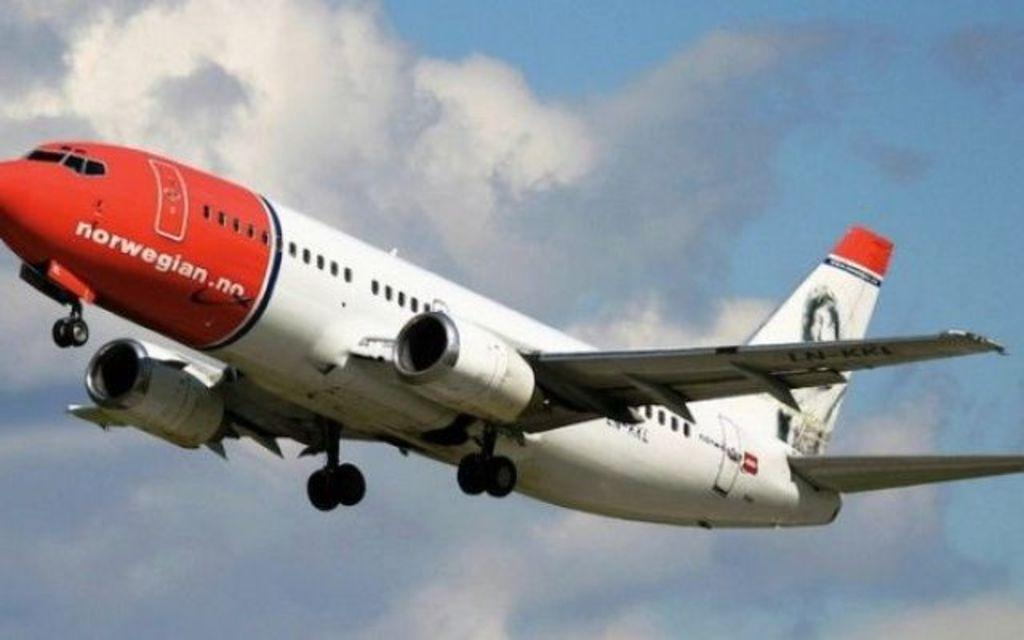Provide a one-sentence caption for the provided image. a red and white air plane with a norwegian airline. 